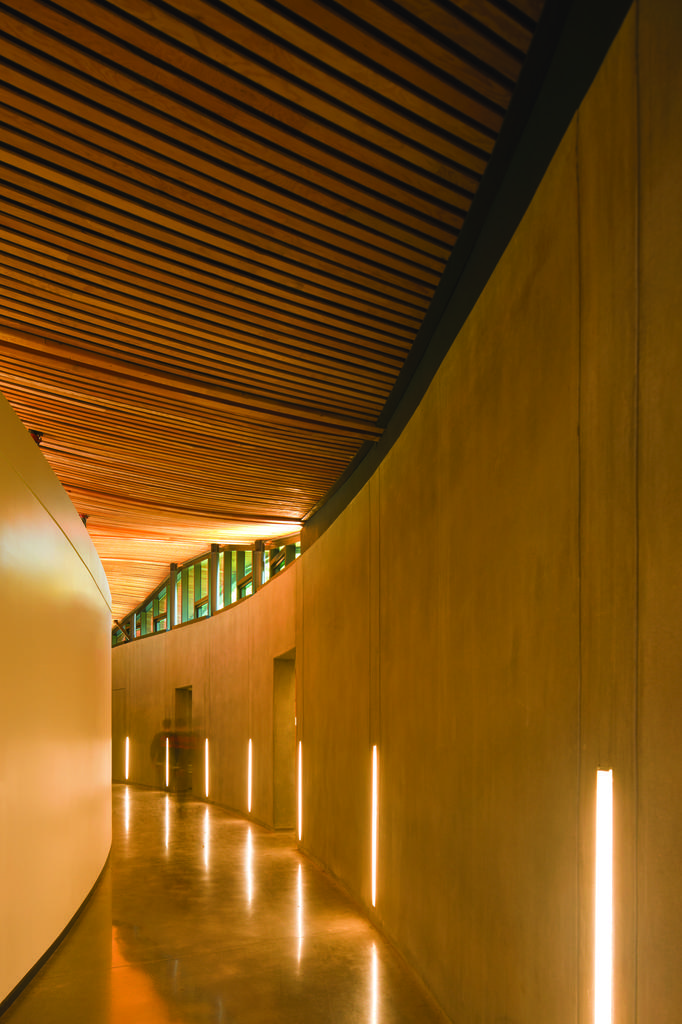How would you summarize this image in a sentence or two? In this image I see the inside view of a building and I see the walls and I see the lights over here and I see the floor. 